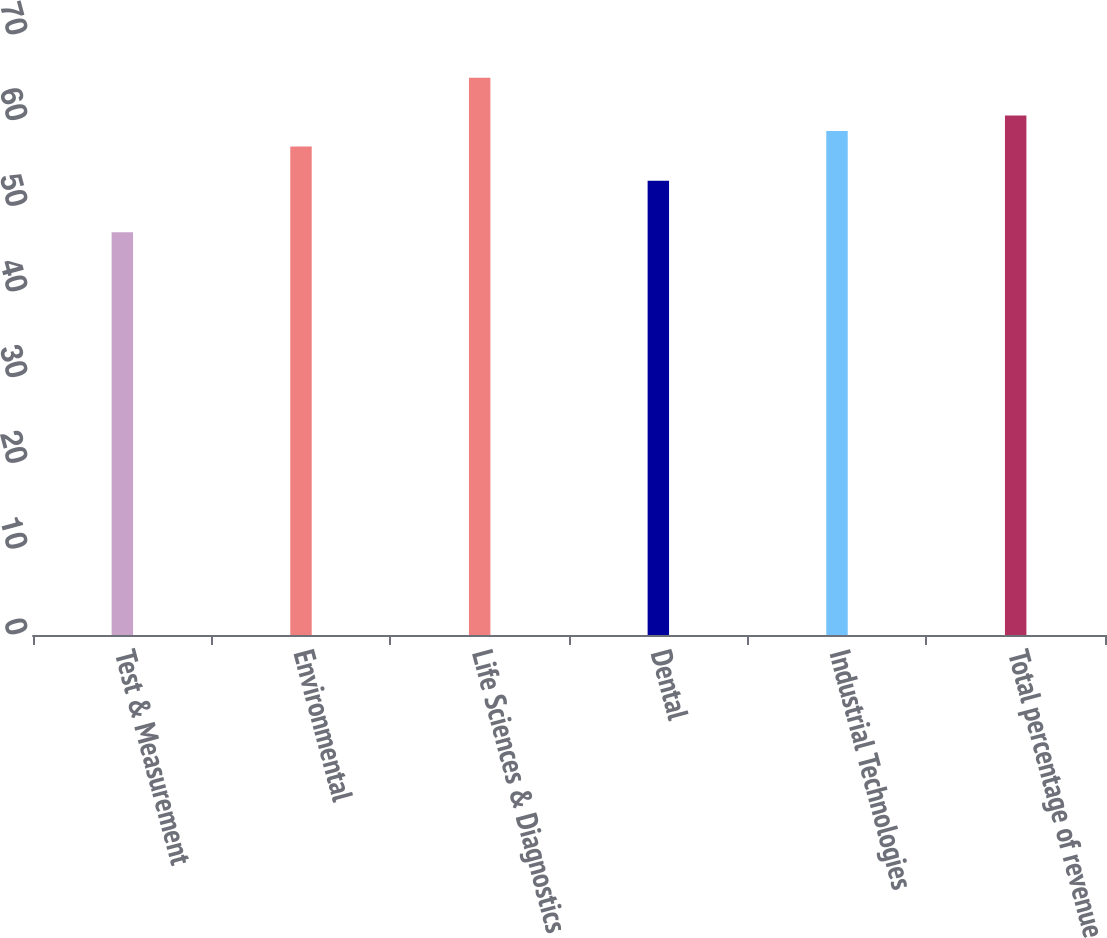Convert chart. <chart><loc_0><loc_0><loc_500><loc_500><bar_chart><fcel>Test & Measurement<fcel>Environmental<fcel>Life Sciences & Diagnostics<fcel>Dental<fcel>Industrial Technologies<fcel>Total percentage of revenue<nl><fcel>47<fcel>57<fcel>65<fcel>53<fcel>58.8<fcel>60.6<nl></chart> 